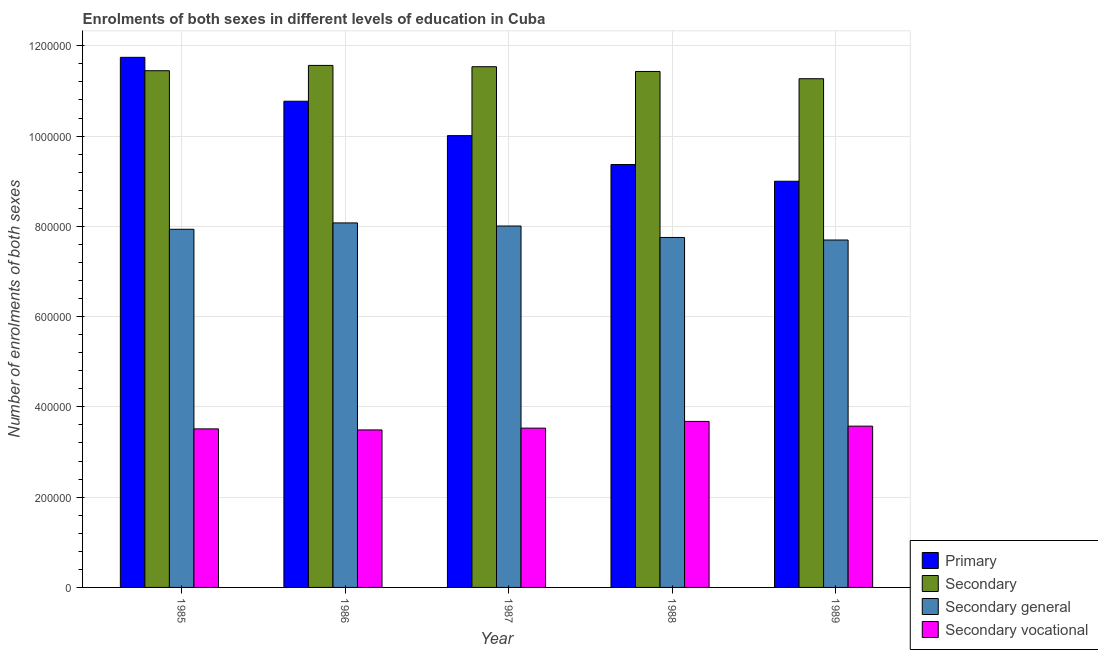How many different coloured bars are there?
Offer a terse response. 4. How many groups of bars are there?
Your response must be concise. 5. Are the number of bars per tick equal to the number of legend labels?
Your response must be concise. Yes. How many bars are there on the 3rd tick from the left?
Offer a very short reply. 4. How many bars are there on the 4th tick from the right?
Your answer should be very brief. 4. In how many cases, is the number of bars for a given year not equal to the number of legend labels?
Ensure brevity in your answer.  0. What is the number of enrolments in secondary general education in 1985?
Your response must be concise. 7.94e+05. Across all years, what is the maximum number of enrolments in primary education?
Make the answer very short. 1.17e+06. Across all years, what is the minimum number of enrolments in secondary general education?
Your response must be concise. 7.70e+05. In which year was the number of enrolments in secondary education maximum?
Ensure brevity in your answer.  1986. In which year was the number of enrolments in secondary general education minimum?
Make the answer very short. 1989. What is the total number of enrolments in primary education in the graph?
Keep it short and to the point. 5.09e+06. What is the difference between the number of enrolments in primary education in 1988 and that in 1989?
Keep it short and to the point. 3.70e+04. What is the difference between the number of enrolments in secondary education in 1985 and the number of enrolments in secondary vocational education in 1988?
Your response must be concise. 1653. What is the average number of enrolments in secondary general education per year?
Offer a very short reply. 7.89e+05. In the year 1988, what is the difference between the number of enrolments in secondary vocational education and number of enrolments in secondary general education?
Make the answer very short. 0. What is the ratio of the number of enrolments in secondary general education in 1987 to that in 1989?
Your answer should be very brief. 1.04. What is the difference between the highest and the second highest number of enrolments in secondary vocational education?
Your answer should be very brief. 1.05e+04. What is the difference between the highest and the lowest number of enrolments in primary education?
Give a very brief answer. 2.75e+05. Is it the case that in every year, the sum of the number of enrolments in secondary general education and number of enrolments in primary education is greater than the sum of number of enrolments in secondary education and number of enrolments in secondary vocational education?
Your answer should be very brief. Yes. What does the 2nd bar from the left in 1988 represents?
Give a very brief answer. Secondary. What does the 1st bar from the right in 1988 represents?
Your answer should be compact. Secondary vocational. Is it the case that in every year, the sum of the number of enrolments in primary education and number of enrolments in secondary education is greater than the number of enrolments in secondary general education?
Offer a very short reply. Yes. How many bars are there?
Make the answer very short. 20. How many years are there in the graph?
Your answer should be very brief. 5. Does the graph contain grids?
Your response must be concise. Yes. What is the title of the graph?
Offer a very short reply. Enrolments of both sexes in different levels of education in Cuba. Does "Burnt food" appear as one of the legend labels in the graph?
Provide a succinct answer. No. What is the label or title of the X-axis?
Ensure brevity in your answer.  Year. What is the label or title of the Y-axis?
Ensure brevity in your answer.  Number of enrolments of both sexes. What is the Number of enrolments of both sexes of Primary in 1985?
Give a very brief answer. 1.17e+06. What is the Number of enrolments of both sexes of Secondary in 1985?
Keep it short and to the point. 1.14e+06. What is the Number of enrolments of both sexes of Secondary general in 1985?
Make the answer very short. 7.94e+05. What is the Number of enrolments of both sexes in Secondary vocational in 1985?
Offer a terse response. 3.51e+05. What is the Number of enrolments of both sexes of Primary in 1986?
Provide a short and direct response. 1.08e+06. What is the Number of enrolments of both sexes in Secondary in 1986?
Make the answer very short. 1.16e+06. What is the Number of enrolments of both sexes of Secondary general in 1986?
Your response must be concise. 8.08e+05. What is the Number of enrolments of both sexes of Secondary vocational in 1986?
Make the answer very short. 3.49e+05. What is the Number of enrolments of both sexes of Primary in 1987?
Keep it short and to the point. 1.00e+06. What is the Number of enrolments of both sexes of Secondary in 1987?
Your answer should be very brief. 1.15e+06. What is the Number of enrolments of both sexes in Secondary general in 1987?
Offer a terse response. 8.01e+05. What is the Number of enrolments of both sexes in Secondary vocational in 1987?
Ensure brevity in your answer.  3.53e+05. What is the Number of enrolments of both sexes of Primary in 1988?
Provide a short and direct response. 9.37e+05. What is the Number of enrolments of both sexes in Secondary in 1988?
Provide a short and direct response. 1.14e+06. What is the Number of enrolments of both sexes of Secondary general in 1988?
Your response must be concise. 7.75e+05. What is the Number of enrolments of both sexes in Secondary vocational in 1988?
Provide a short and direct response. 3.68e+05. What is the Number of enrolments of both sexes of Primary in 1989?
Offer a terse response. 9.00e+05. What is the Number of enrolments of both sexes of Secondary in 1989?
Provide a short and direct response. 1.13e+06. What is the Number of enrolments of both sexes of Secondary general in 1989?
Give a very brief answer. 7.70e+05. What is the Number of enrolments of both sexes in Secondary vocational in 1989?
Provide a short and direct response. 3.57e+05. Across all years, what is the maximum Number of enrolments of both sexes of Primary?
Make the answer very short. 1.17e+06. Across all years, what is the maximum Number of enrolments of both sexes of Secondary?
Provide a short and direct response. 1.16e+06. Across all years, what is the maximum Number of enrolments of both sexes of Secondary general?
Ensure brevity in your answer.  8.08e+05. Across all years, what is the maximum Number of enrolments of both sexes of Secondary vocational?
Provide a short and direct response. 3.68e+05. Across all years, what is the minimum Number of enrolments of both sexes of Primary?
Your answer should be compact. 9.00e+05. Across all years, what is the minimum Number of enrolments of both sexes in Secondary?
Offer a very short reply. 1.13e+06. Across all years, what is the minimum Number of enrolments of both sexes in Secondary general?
Your answer should be compact. 7.70e+05. Across all years, what is the minimum Number of enrolments of both sexes of Secondary vocational?
Give a very brief answer. 3.49e+05. What is the total Number of enrolments of both sexes of Primary in the graph?
Provide a succinct answer. 5.09e+06. What is the total Number of enrolments of both sexes in Secondary in the graph?
Your response must be concise. 5.73e+06. What is the total Number of enrolments of both sexes of Secondary general in the graph?
Provide a succinct answer. 3.95e+06. What is the total Number of enrolments of both sexes of Secondary vocational in the graph?
Keep it short and to the point. 1.78e+06. What is the difference between the Number of enrolments of both sexes in Primary in 1985 and that in 1986?
Provide a short and direct response. 9.72e+04. What is the difference between the Number of enrolments of both sexes of Secondary in 1985 and that in 1986?
Offer a terse response. -1.18e+04. What is the difference between the Number of enrolments of both sexes of Secondary general in 1985 and that in 1986?
Provide a short and direct response. -1.41e+04. What is the difference between the Number of enrolments of both sexes in Secondary vocational in 1985 and that in 1986?
Offer a very short reply. 2316. What is the difference between the Number of enrolments of both sexes of Primary in 1985 and that in 1987?
Offer a very short reply. 1.73e+05. What is the difference between the Number of enrolments of both sexes in Secondary in 1985 and that in 1987?
Offer a terse response. -8869. What is the difference between the Number of enrolments of both sexes in Secondary general in 1985 and that in 1987?
Provide a succinct answer. -7216. What is the difference between the Number of enrolments of both sexes in Secondary vocational in 1985 and that in 1987?
Your response must be concise. -1653. What is the difference between the Number of enrolments of both sexes of Primary in 1985 and that in 1988?
Your response must be concise. 2.38e+05. What is the difference between the Number of enrolments of both sexes in Secondary in 1985 and that in 1988?
Offer a very short reply. 1653. What is the difference between the Number of enrolments of both sexes in Secondary general in 1985 and that in 1988?
Keep it short and to the point. 1.82e+04. What is the difference between the Number of enrolments of both sexes in Secondary vocational in 1985 and that in 1988?
Ensure brevity in your answer.  -1.65e+04. What is the difference between the Number of enrolments of both sexes of Primary in 1985 and that in 1989?
Keep it short and to the point. 2.75e+05. What is the difference between the Number of enrolments of both sexes of Secondary in 1985 and that in 1989?
Your answer should be compact. 1.78e+04. What is the difference between the Number of enrolments of both sexes in Secondary general in 1985 and that in 1989?
Keep it short and to the point. 2.38e+04. What is the difference between the Number of enrolments of both sexes of Secondary vocational in 1985 and that in 1989?
Give a very brief answer. -6047. What is the difference between the Number of enrolments of both sexes in Primary in 1986 and that in 1987?
Your response must be concise. 7.62e+04. What is the difference between the Number of enrolments of both sexes of Secondary in 1986 and that in 1987?
Offer a very short reply. 2896. What is the difference between the Number of enrolments of both sexes of Secondary general in 1986 and that in 1987?
Provide a short and direct response. 6865. What is the difference between the Number of enrolments of both sexes in Secondary vocational in 1986 and that in 1987?
Keep it short and to the point. -3969. What is the difference between the Number of enrolments of both sexes in Primary in 1986 and that in 1988?
Provide a short and direct response. 1.40e+05. What is the difference between the Number of enrolments of both sexes of Secondary in 1986 and that in 1988?
Your answer should be compact. 1.34e+04. What is the difference between the Number of enrolments of both sexes of Secondary general in 1986 and that in 1988?
Your response must be concise. 3.23e+04. What is the difference between the Number of enrolments of both sexes of Secondary vocational in 1986 and that in 1988?
Offer a very short reply. -1.88e+04. What is the difference between the Number of enrolments of both sexes in Primary in 1986 and that in 1989?
Provide a succinct answer. 1.77e+05. What is the difference between the Number of enrolments of both sexes in Secondary in 1986 and that in 1989?
Offer a very short reply. 2.95e+04. What is the difference between the Number of enrolments of both sexes in Secondary general in 1986 and that in 1989?
Make the answer very short. 3.79e+04. What is the difference between the Number of enrolments of both sexes in Secondary vocational in 1986 and that in 1989?
Your answer should be compact. -8363. What is the difference between the Number of enrolments of both sexes in Primary in 1987 and that in 1988?
Your answer should be compact. 6.41e+04. What is the difference between the Number of enrolments of both sexes in Secondary in 1987 and that in 1988?
Your response must be concise. 1.05e+04. What is the difference between the Number of enrolments of both sexes in Secondary general in 1987 and that in 1988?
Offer a terse response. 2.54e+04. What is the difference between the Number of enrolments of both sexes in Secondary vocational in 1987 and that in 1988?
Your answer should be very brief. -1.49e+04. What is the difference between the Number of enrolments of both sexes of Primary in 1987 and that in 1989?
Ensure brevity in your answer.  1.01e+05. What is the difference between the Number of enrolments of both sexes in Secondary in 1987 and that in 1989?
Your answer should be very brief. 2.66e+04. What is the difference between the Number of enrolments of both sexes of Secondary general in 1987 and that in 1989?
Your response must be concise. 3.10e+04. What is the difference between the Number of enrolments of both sexes of Secondary vocational in 1987 and that in 1989?
Keep it short and to the point. -4394. What is the difference between the Number of enrolments of both sexes of Primary in 1988 and that in 1989?
Your answer should be very brief. 3.70e+04. What is the difference between the Number of enrolments of both sexes in Secondary in 1988 and that in 1989?
Give a very brief answer. 1.61e+04. What is the difference between the Number of enrolments of both sexes in Secondary general in 1988 and that in 1989?
Make the answer very short. 5631. What is the difference between the Number of enrolments of both sexes in Secondary vocational in 1988 and that in 1989?
Ensure brevity in your answer.  1.05e+04. What is the difference between the Number of enrolments of both sexes in Primary in 1985 and the Number of enrolments of both sexes in Secondary in 1986?
Keep it short and to the point. 1.79e+04. What is the difference between the Number of enrolments of both sexes in Primary in 1985 and the Number of enrolments of both sexes in Secondary general in 1986?
Ensure brevity in your answer.  3.67e+05. What is the difference between the Number of enrolments of both sexes of Primary in 1985 and the Number of enrolments of both sexes of Secondary vocational in 1986?
Your answer should be very brief. 8.25e+05. What is the difference between the Number of enrolments of both sexes in Secondary in 1985 and the Number of enrolments of both sexes in Secondary general in 1986?
Keep it short and to the point. 3.37e+05. What is the difference between the Number of enrolments of both sexes of Secondary in 1985 and the Number of enrolments of both sexes of Secondary vocational in 1986?
Provide a succinct answer. 7.96e+05. What is the difference between the Number of enrolments of both sexes in Secondary general in 1985 and the Number of enrolments of both sexes in Secondary vocational in 1986?
Offer a terse response. 4.45e+05. What is the difference between the Number of enrolments of both sexes in Primary in 1985 and the Number of enrolments of both sexes in Secondary in 1987?
Provide a short and direct response. 2.08e+04. What is the difference between the Number of enrolments of both sexes in Primary in 1985 and the Number of enrolments of both sexes in Secondary general in 1987?
Provide a succinct answer. 3.74e+05. What is the difference between the Number of enrolments of both sexes of Primary in 1985 and the Number of enrolments of both sexes of Secondary vocational in 1987?
Make the answer very short. 8.22e+05. What is the difference between the Number of enrolments of both sexes of Secondary in 1985 and the Number of enrolments of both sexes of Secondary general in 1987?
Make the answer very short. 3.44e+05. What is the difference between the Number of enrolments of both sexes in Secondary in 1985 and the Number of enrolments of both sexes in Secondary vocational in 1987?
Offer a very short reply. 7.92e+05. What is the difference between the Number of enrolments of both sexes in Secondary general in 1985 and the Number of enrolments of both sexes in Secondary vocational in 1987?
Make the answer very short. 4.41e+05. What is the difference between the Number of enrolments of both sexes in Primary in 1985 and the Number of enrolments of both sexes in Secondary in 1988?
Your answer should be compact. 3.13e+04. What is the difference between the Number of enrolments of both sexes in Primary in 1985 and the Number of enrolments of both sexes in Secondary general in 1988?
Keep it short and to the point. 3.99e+05. What is the difference between the Number of enrolments of both sexes in Primary in 1985 and the Number of enrolments of both sexes in Secondary vocational in 1988?
Your answer should be compact. 8.07e+05. What is the difference between the Number of enrolments of both sexes in Secondary in 1985 and the Number of enrolments of both sexes in Secondary general in 1988?
Your answer should be compact. 3.69e+05. What is the difference between the Number of enrolments of both sexes in Secondary in 1985 and the Number of enrolments of both sexes in Secondary vocational in 1988?
Your answer should be compact. 7.77e+05. What is the difference between the Number of enrolments of both sexes in Secondary general in 1985 and the Number of enrolments of both sexes in Secondary vocational in 1988?
Keep it short and to the point. 4.26e+05. What is the difference between the Number of enrolments of both sexes of Primary in 1985 and the Number of enrolments of both sexes of Secondary in 1989?
Make the answer very short. 4.74e+04. What is the difference between the Number of enrolments of both sexes in Primary in 1985 and the Number of enrolments of both sexes in Secondary general in 1989?
Your answer should be very brief. 4.05e+05. What is the difference between the Number of enrolments of both sexes in Primary in 1985 and the Number of enrolments of both sexes in Secondary vocational in 1989?
Make the answer very short. 8.17e+05. What is the difference between the Number of enrolments of both sexes of Secondary in 1985 and the Number of enrolments of both sexes of Secondary general in 1989?
Ensure brevity in your answer.  3.75e+05. What is the difference between the Number of enrolments of both sexes of Secondary in 1985 and the Number of enrolments of both sexes of Secondary vocational in 1989?
Provide a short and direct response. 7.87e+05. What is the difference between the Number of enrolments of both sexes in Secondary general in 1985 and the Number of enrolments of both sexes in Secondary vocational in 1989?
Your answer should be compact. 4.36e+05. What is the difference between the Number of enrolments of both sexes in Primary in 1986 and the Number of enrolments of both sexes in Secondary in 1987?
Give a very brief answer. -7.64e+04. What is the difference between the Number of enrolments of both sexes of Primary in 1986 and the Number of enrolments of both sexes of Secondary general in 1987?
Keep it short and to the point. 2.76e+05. What is the difference between the Number of enrolments of both sexes in Primary in 1986 and the Number of enrolments of both sexes in Secondary vocational in 1987?
Provide a short and direct response. 7.24e+05. What is the difference between the Number of enrolments of both sexes of Secondary in 1986 and the Number of enrolments of both sexes of Secondary general in 1987?
Your answer should be compact. 3.56e+05. What is the difference between the Number of enrolments of both sexes in Secondary in 1986 and the Number of enrolments of both sexes in Secondary vocational in 1987?
Your response must be concise. 8.04e+05. What is the difference between the Number of enrolments of both sexes of Secondary general in 1986 and the Number of enrolments of both sexes of Secondary vocational in 1987?
Provide a succinct answer. 4.55e+05. What is the difference between the Number of enrolments of both sexes in Primary in 1986 and the Number of enrolments of both sexes in Secondary in 1988?
Make the answer very short. -6.59e+04. What is the difference between the Number of enrolments of both sexes in Primary in 1986 and the Number of enrolments of both sexes in Secondary general in 1988?
Provide a short and direct response. 3.02e+05. What is the difference between the Number of enrolments of both sexes in Primary in 1986 and the Number of enrolments of both sexes in Secondary vocational in 1988?
Give a very brief answer. 7.09e+05. What is the difference between the Number of enrolments of both sexes in Secondary in 1986 and the Number of enrolments of both sexes in Secondary general in 1988?
Ensure brevity in your answer.  3.81e+05. What is the difference between the Number of enrolments of both sexes of Secondary in 1986 and the Number of enrolments of both sexes of Secondary vocational in 1988?
Provide a succinct answer. 7.89e+05. What is the difference between the Number of enrolments of both sexes of Secondary general in 1986 and the Number of enrolments of both sexes of Secondary vocational in 1988?
Ensure brevity in your answer.  4.40e+05. What is the difference between the Number of enrolments of both sexes in Primary in 1986 and the Number of enrolments of both sexes in Secondary in 1989?
Offer a very short reply. -4.98e+04. What is the difference between the Number of enrolments of both sexes in Primary in 1986 and the Number of enrolments of both sexes in Secondary general in 1989?
Offer a very short reply. 3.07e+05. What is the difference between the Number of enrolments of both sexes in Primary in 1986 and the Number of enrolments of both sexes in Secondary vocational in 1989?
Keep it short and to the point. 7.20e+05. What is the difference between the Number of enrolments of both sexes in Secondary in 1986 and the Number of enrolments of both sexes in Secondary general in 1989?
Offer a very short reply. 3.87e+05. What is the difference between the Number of enrolments of both sexes in Secondary in 1986 and the Number of enrolments of both sexes in Secondary vocational in 1989?
Keep it short and to the point. 7.99e+05. What is the difference between the Number of enrolments of both sexes in Secondary general in 1986 and the Number of enrolments of both sexes in Secondary vocational in 1989?
Offer a terse response. 4.50e+05. What is the difference between the Number of enrolments of both sexes of Primary in 1987 and the Number of enrolments of both sexes of Secondary in 1988?
Your response must be concise. -1.42e+05. What is the difference between the Number of enrolments of both sexes of Primary in 1987 and the Number of enrolments of both sexes of Secondary general in 1988?
Give a very brief answer. 2.26e+05. What is the difference between the Number of enrolments of both sexes of Primary in 1987 and the Number of enrolments of both sexes of Secondary vocational in 1988?
Your response must be concise. 6.33e+05. What is the difference between the Number of enrolments of both sexes of Secondary in 1987 and the Number of enrolments of both sexes of Secondary general in 1988?
Your answer should be very brief. 3.78e+05. What is the difference between the Number of enrolments of both sexes of Secondary in 1987 and the Number of enrolments of both sexes of Secondary vocational in 1988?
Ensure brevity in your answer.  7.86e+05. What is the difference between the Number of enrolments of both sexes in Secondary general in 1987 and the Number of enrolments of both sexes in Secondary vocational in 1988?
Provide a short and direct response. 4.33e+05. What is the difference between the Number of enrolments of both sexes in Primary in 1987 and the Number of enrolments of both sexes in Secondary in 1989?
Your response must be concise. -1.26e+05. What is the difference between the Number of enrolments of both sexes of Primary in 1987 and the Number of enrolments of both sexes of Secondary general in 1989?
Provide a short and direct response. 2.31e+05. What is the difference between the Number of enrolments of both sexes of Primary in 1987 and the Number of enrolments of both sexes of Secondary vocational in 1989?
Offer a very short reply. 6.44e+05. What is the difference between the Number of enrolments of both sexes in Secondary in 1987 and the Number of enrolments of both sexes in Secondary general in 1989?
Your response must be concise. 3.84e+05. What is the difference between the Number of enrolments of both sexes in Secondary in 1987 and the Number of enrolments of both sexes in Secondary vocational in 1989?
Provide a short and direct response. 7.96e+05. What is the difference between the Number of enrolments of both sexes in Secondary general in 1987 and the Number of enrolments of both sexes in Secondary vocational in 1989?
Ensure brevity in your answer.  4.43e+05. What is the difference between the Number of enrolments of both sexes of Primary in 1988 and the Number of enrolments of both sexes of Secondary in 1989?
Make the answer very short. -1.90e+05. What is the difference between the Number of enrolments of both sexes of Primary in 1988 and the Number of enrolments of both sexes of Secondary general in 1989?
Your response must be concise. 1.67e+05. What is the difference between the Number of enrolments of both sexes of Primary in 1988 and the Number of enrolments of both sexes of Secondary vocational in 1989?
Offer a terse response. 5.80e+05. What is the difference between the Number of enrolments of both sexes in Secondary in 1988 and the Number of enrolments of both sexes in Secondary general in 1989?
Keep it short and to the point. 3.73e+05. What is the difference between the Number of enrolments of both sexes of Secondary in 1988 and the Number of enrolments of both sexes of Secondary vocational in 1989?
Offer a terse response. 7.86e+05. What is the difference between the Number of enrolments of both sexes of Secondary general in 1988 and the Number of enrolments of both sexes of Secondary vocational in 1989?
Your answer should be very brief. 4.18e+05. What is the average Number of enrolments of both sexes of Primary per year?
Give a very brief answer. 1.02e+06. What is the average Number of enrolments of both sexes in Secondary per year?
Give a very brief answer. 1.15e+06. What is the average Number of enrolments of both sexes in Secondary general per year?
Keep it short and to the point. 7.89e+05. What is the average Number of enrolments of both sexes in Secondary vocational per year?
Offer a very short reply. 3.56e+05. In the year 1985, what is the difference between the Number of enrolments of both sexes in Primary and Number of enrolments of both sexes in Secondary?
Provide a short and direct response. 2.97e+04. In the year 1985, what is the difference between the Number of enrolments of both sexes of Primary and Number of enrolments of both sexes of Secondary general?
Give a very brief answer. 3.81e+05. In the year 1985, what is the difference between the Number of enrolments of both sexes in Primary and Number of enrolments of both sexes in Secondary vocational?
Keep it short and to the point. 8.23e+05. In the year 1985, what is the difference between the Number of enrolments of both sexes in Secondary and Number of enrolments of both sexes in Secondary general?
Offer a very short reply. 3.51e+05. In the year 1985, what is the difference between the Number of enrolments of both sexes in Secondary and Number of enrolments of both sexes in Secondary vocational?
Keep it short and to the point. 7.94e+05. In the year 1985, what is the difference between the Number of enrolments of both sexes of Secondary general and Number of enrolments of both sexes of Secondary vocational?
Keep it short and to the point. 4.42e+05. In the year 1986, what is the difference between the Number of enrolments of both sexes in Primary and Number of enrolments of both sexes in Secondary?
Offer a terse response. -7.93e+04. In the year 1986, what is the difference between the Number of enrolments of both sexes in Primary and Number of enrolments of both sexes in Secondary general?
Offer a terse response. 2.70e+05. In the year 1986, what is the difference between the Number of enrolments of both sexes of Primary and Number of enrolments of both sexes of Secondary vocational?
Your response must be concise. 7.28e+05. In the year 1986, what is the difference between the Number of enrolments of both sexes of Secondary and Number of enrolments of both sexes of Secondary general?
Offer a very short reply. 3.49e+05. In the year 1986, what is the difference between the Number of enrolments of both sexes in Secondary and Number of enrolments of both sexes in Secondary vocational?
Make the answer very short. 8.08e+05. In the year 1986, what is the difference between the Number of enrolments of both sexes of Secondary general and Number of enrolments of both sexes of Secondary vocational?
Your answer should be compact. 4.59e+05. In the year 1987, what is the difference between the Number of enrolments of both sexes in Primary and Number of enrolments of both sexes in Secondary?
Your answer should be compact. -1.53e+05. In the year 1987, what is the difference between the Number of enrolments of both sexes in Primary and Number of enrolments of both sexes in Secondary general?
Ensure brevity in your answer.  2.00e+05. In the year 1987, what is the difference between the Number of enrolments of both sexes in Primary and Number of enrolments of both sexes in Secondary vocational?
Offer a very short reply. 6.48e+05. In the year 1987, what is the difference between the Number of enrolments of both sexes of Secondary and Number of enrolments of both sexes of Secondary general?
Your answer should be compact. 3.53e+05. In the year 1987, what is the difference between the Number of enrolments of both sexes of Secondary and Number of enrolments of both sexes of Secondary vocational?
Ensure brevity in your answer.  8.01e+05. In the year 1987, what is the difference between the Number of enrolments of both sexes in Secondary general and Number of enrolments of both sexes in Secondary vocational?
Provide a succinct answer. 4.48e+05. In the year 1988, what is the difference between the Number of enrolments of both sexes in Primary and Number of enrolments of both sexes in Secondary?
Offer a very short reply. -2.06e+05. In the year 1988, what is the difference between the Number of enrolments of both sexes of Primary and Number of enrolments of both sexes of Secondary general?
Offer a very short reply. 1.62e+05. In the year 1988, what is the difference between the Number of enrolments of both sexes in Primary and Number of enrolments of both sexes in Secondary vocational?
Your response must be concise. 5.69e+05. In the year 1988, what is the difference between the Number of enrolments of both sexes of Secondary and Number of enrolments of both sexes of Secondary general?
Make the answer very short. 3.68e+05. In the year 1988, what is the difference between the Number of enrolments of both sexes of Secondary and Number of enrolments of both sexes of Secondary vocational?
Offer a very short reply. 7.75e+05. In the year 1988, what is the difference between the Number of enrolments of both sexes in Secondary general and Number of enrolments of both sexes in Secondary vocational?
Provide a short and direct response. 4.08e+05. In the year 1989, what is the difference between the Number of enrolments of both sexes in Primary and Number of enrolments of both sexes in Secondary?
Give a very brief answer. -2.27e+05. In the year 1989, what is the difference between the Number of enrolments of both sexes in Primary and Number of enrolments of both sexes in Secondary general?
Ensure brevity in your answer.  1.30e+05. In the year 1989, what is the difference between the Number of enrolments of both sexes in Primary and Number of enrolments of both sexes in Secondary vocational?
Offer a terse response. 5.43e+05. In the year 1989, what is the difference between the Number of enrolments of both sexes of Secondary and Number of enrolments of both sexes of Secondary general?
Keep it short and to the point. 3.57e+05. In the year 1989, what is the difference between the Number of enrolments of both sexes of Secondary and Number of enrolments of both sexes of Secondary vocational?
Offer a terse response. 7.70e+05. In the year 1989, what is the difference between the Number of enrolments of both sexes in Secondary general and Number of enrolments of both sexes in Secondary vocational?
Give a very brief answer. 4.12e+05. What is the ratio of the Number of enrolments of both sexes in Primary in 1985 to that in 1986?
Ensure brevity in your answer.  1.09. What is the ratio of the Number of enrolments of both sexes in Secondary general in 1985 to that in 1986?
Your response must be concise. 0.98. What is the ratio of the Number of enrolments of both sexes of Secondary vocational in 1985 to that in 1986?
Provide a short and direct response. 1.01. What is the ratio of the Number of enrolments of both sexes of Primary in 1985 to that in 1987?
Provide a succinct answer. 1.17. What is the ratio of the Number of enrolments of both sexes in Secondary in 1985 to that in 1987?
Your answer should be very brief. 0.99. What is the ratio of the Number of enrolments of both sexes in Primary in 1985 to that in 1988?
Your answer should be very brief. 1.25. What is the ratio of the Number of enrolments of both sexes of Secondary in 1985 to that in 1988?
Provide a short and direct response. 1. What is the ratio of the Number of enrolments of both sexes of Secondary general in 1985 to that in 1988?
Provide a short and direct response. 1.02. What is the ratio of the Number of enrolments of both sexes of Secondary vocational in 1985 to that in 1988?
Your answer should be compact. 0.96. What is the ratio of the Number of enrolments of both sexes in Primary in 1985 to that in 1989?
Make the answer very short. 1.3. What is the ratio of the Number of enrolments of both sexes of Secondary in 1985 to that in 1989?
Make the answer very short. 1.02. What is the ratio of the Number of enrolments of both sexes of Secondary general in 1985 to that in 1989?
Provide a succinct answer. 1.03. What is the ratio of the Number of enrolments of both sexes in Secondary vocational in 1985 to that in 1989?
Your answer should be very brief. 0.98. What is the ratio of the Number of enrolments of both sexes of Primary in 1986 to that in 1987?
Give a very brief answer. 1.08. What is the ratio of the Number of enrolments of both sexes in Secondary in 1986 to that in 1987?
Offer a terse response. 1. What is the ratio of the Number of enrolments of both sexes in Secondary general in 1986 to that in 1987?
Keep it short and to the point. 1.01. What is the ratio of the Number of enrolments of both sexes of Primary in 1986 to that in 1988?
Offer a terse response. 1.15. What is the ratio of the Number of enrolments of both sexes of Secondary in 1986 to that in 1988?
Keep it short and to the point. 1.01. What is the ratio of the Number of enrolments of both sexes of Secondary general in 1986 to that in 1988?
Make the answer very short. 1.04. What is the ratio of the Number of enrolments of both sexes of Secondary vocational in 1986 to that in 1988?
Keep it short and to the point. 0.95. What is the ratio of the Number of enrolments of both sexes in Primary in 1986 to that in 1989?
Offer a terse response. 1.2. What is the ratio of the Number of enrolments of both sexes in Secondary in 1986 to that in 1989?
Provide a short and direct response. 1.03. What is the ratio of the Number of enrolments of both sexes in Secondary general in 1986 to that in 1989?
Give a very brief answer. 1.05. What is the ratio of the Number of enrolments of both sexes of Secondary vocational in 1986 to that in 1989?
Provide a short and direct response. 0.98. What is the ratio of the Number of enrolments of both sexes of Primary in 1987 to that in 1988?
Your answer should be very brief. 1.07. What is the ratio of the Number of enrolments of both sexes in Secondary in 1987 to that in 1988?
Provide a short and direct response. 1.01. What is the ratio of the Number of enrolments of both sexes in Secondary general in 1987 to that in 1988?
Offer a very short reply. 1.03. What is the ratio of the Number of enrolments of both sexes in Secondary vocational in 1987 to that in 1988?
Offer a very short reply. 0.96. What is the ratio of the Number of enrolments of both sexes of Primary in 1987 to that in 1989?
Offer a very short reply. 1.11. What is the ratio of the Number of enrolments of both sexes in Secondary in 1987 to that in 1989?
Offer a terse response. 1.02. What is the ratio of the Number of enrolments of both sexes of Secondary general in 1987 to that in 1989?
Ensure brevity in your answer.  1.04. What is the ratio of the Number of enrolments of both sexes of Primary in 1988 to that in 1989?
Offer a terse response. 1.04. What is the ratio of the Number of enrolments of both sexes in Secondary in 1988 to that in 1989?
Keep it short and to the point. 1.01. What is the ratio of the Number of enrolments of both sexes in Secondary general in 1988 to that in 1989?
Provide a succinct answer. 1.01. What is the ratio of the Number of enrolments of both sexes in Secondary vocational in 1988 to that in 1989?
Offer a terse response. 1.03. What is the difference between the highest and the second highest Number of enrolments of both sexes of Primary?
Your answer should be compact. 9.72e+04. What is the difference between the highest and the second highest Number of enrolments of both sexes in Secondary?
Ensure brevity in your answer.  2896. What is the difference between the highest and the second highest Number of enrolments of both sexes in Secondary general?
Offer a very short reply. 6865. What is the difference between the highest and the second highest Number of enrolments of both sexes of Secondary vocational?
Provide a short and direct response. 1.05e+04. What is the difference between the highest and the lowest Number of enrolments of both sexes in Primary?
Provide a succinct answer. 2.75e+05. What is the difference between the highest and the lowest Number of enrolments of both sexes of Secondary?
Keep it short and to the point. 2.95e+04. What is the difference between the highest and the lowest Number of enrolments of both sexes of Secondary general?
Your answer should be very brief. 3.79e+04. What is the difference between the highest and the lowest Number of enrolments of both sexes of Secondary vocational?
Your answer should be compact. 1.88e+04. 